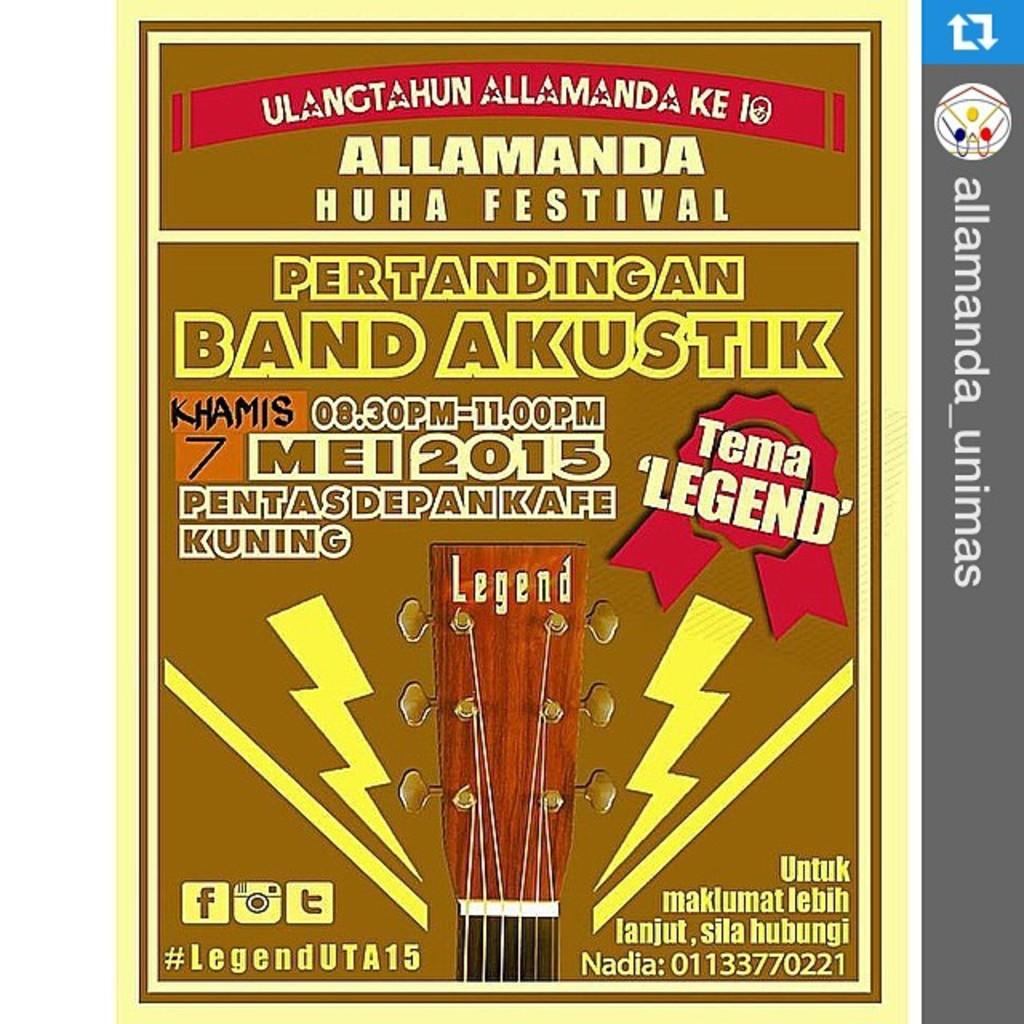What festival is being talked about?
Your answer should be compact. Allamanda huha. 